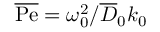<formula> <loc_0><loc_0><loc_500><loc_500>\overline { P e } = \omega _ { 0 } ^ { 2 } / \overline { D } _ { 0 } k _ { 0 }</formula> 